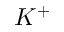<formula> <loc_0><loc_0><loc_500><loc_500>K ^ { + }</formula> 